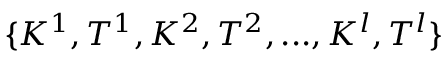<formula> <loc_0><loc_0><loc_500><loc_500>\{ K ^ { 1 } , T ^ { 1 } , K ^ { 2 } , T ^ { 2 } , \dots , K ^ { l } , T ^ { l } \}</formula> 